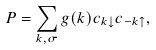<formula> <loc_0><loc_0><loc_500><loc_500>P = \sum _ { k , \sigma } g ( k ) c _ { k \downarrow } c _ { - k \uparrow } ,</formula> 